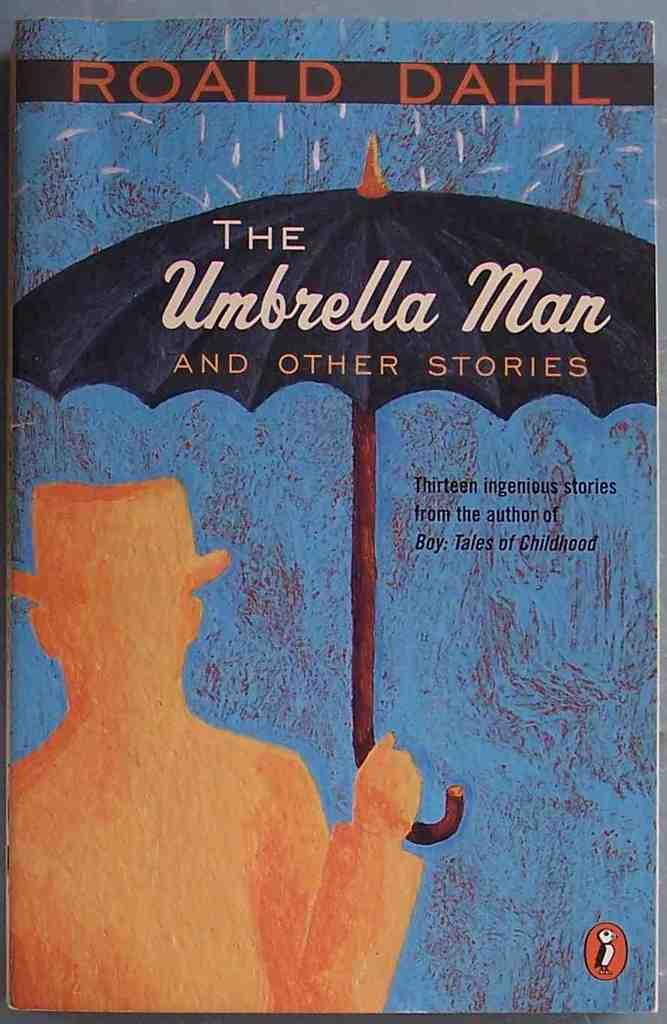<image>
Relay a brief, clear account of the picture shown. A copy of the book The Umbrella Man and Other Stories by Roald Dahl. 